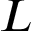<formula> <loc_0><loc_0><loc_500><loc_500>L</formula> 